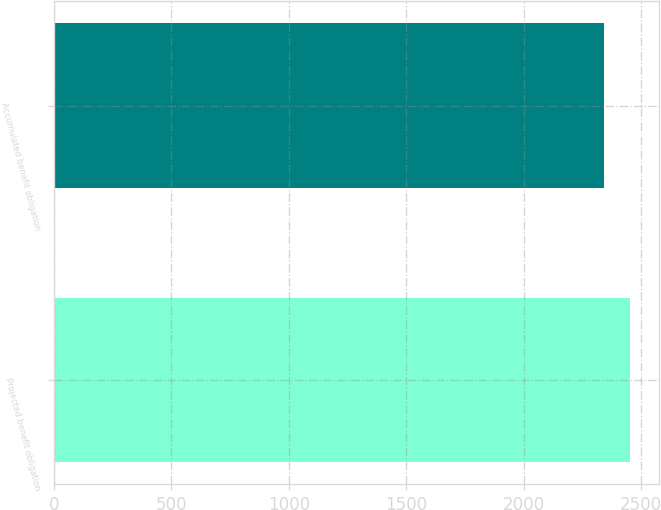<chart> <loc_0><loc_0><loc_500><loc_500><bar_chart><fcel>Projected benefit obligation<fcel>Accumulated benefit obligation<nl><fcel>2452<fcel>2342<nl></chart> 